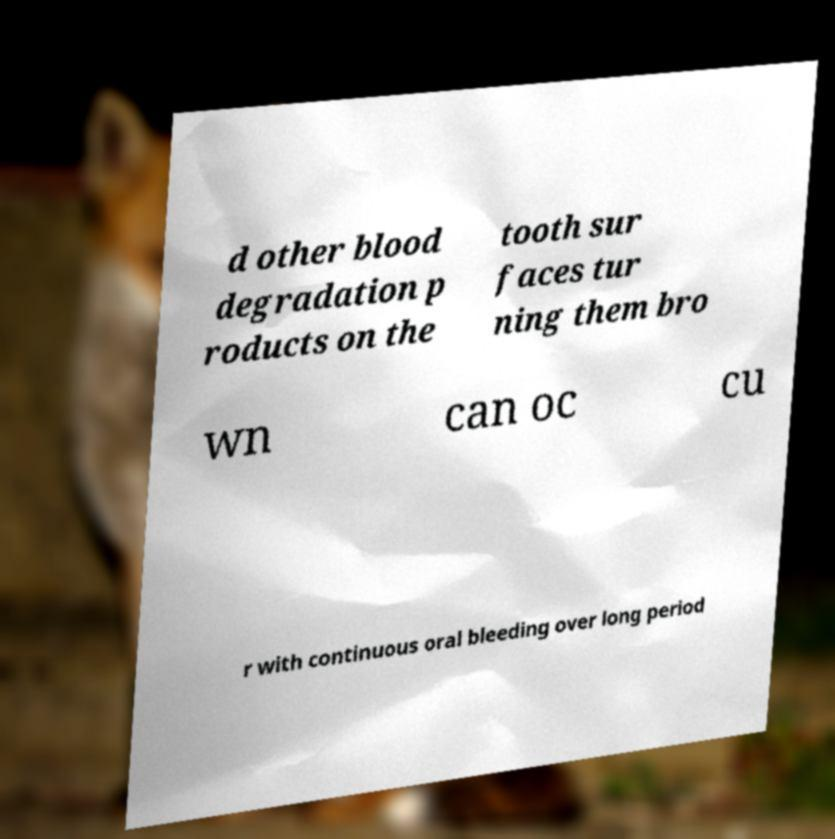I need the written content from this picture converted into text. Can you do that? d other blood degradation p roducts on the tooth sur faces tur ning them bro wn can oc cu r with continuous oral bleeding over long period 